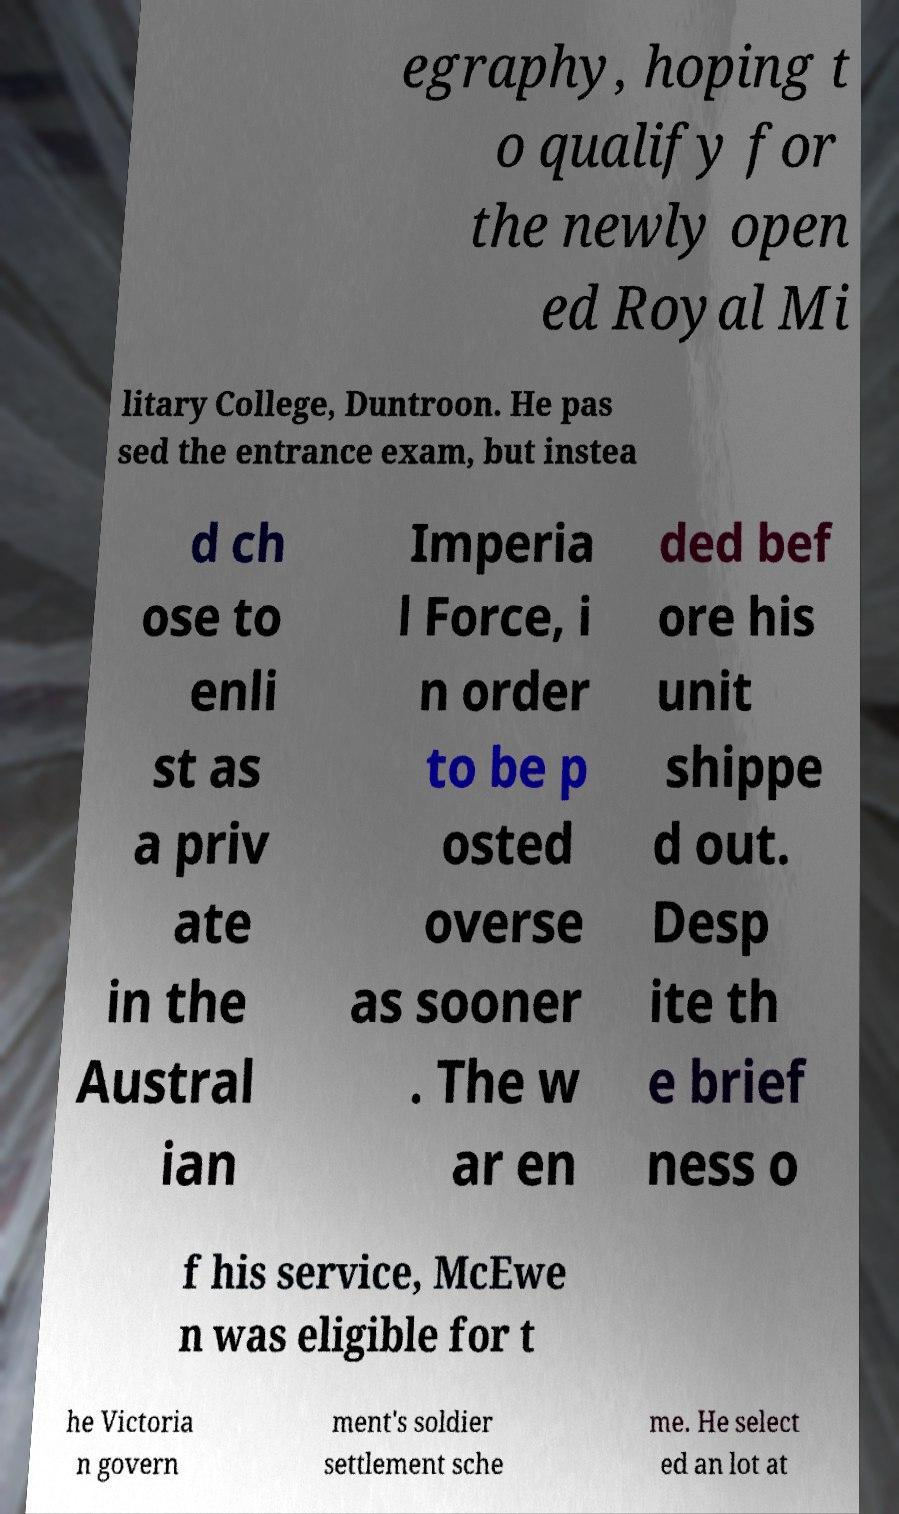Could you assist in decoding the text presented in this image and type it out clearly? egraphy, hoping t o qualify for the newly open ed Royal Mi litary College, Duntroon. He pas sed the entrance exam, but instea d ch ose to enli st as a priv ate in the Austral ian Imperia l Force, i n order to be p osted overse as sooner . The w ar en ded bef ore his unit shippe d out. Desp ite th e brief ness o f his service, McEwe n was eligible for t he Victoria n govern ment's soldier settlement sche me. He select ed an lot at 